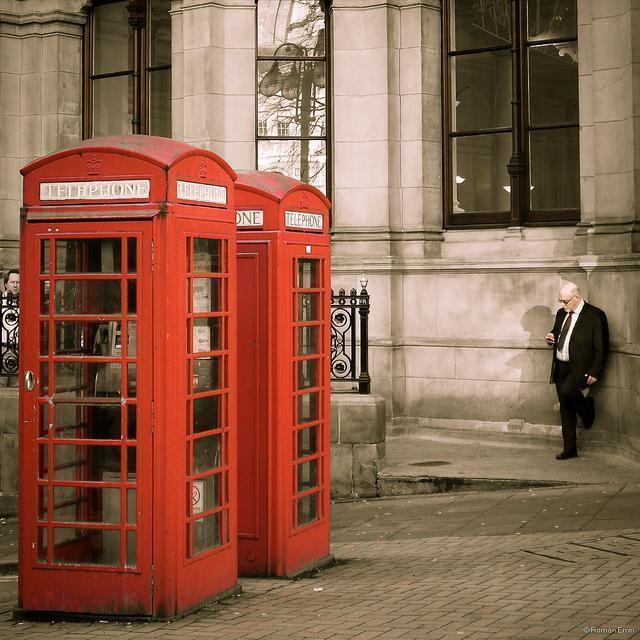If the gentleman here in the suit wants to call his sweetheart where will he do it?
Select the accurate response from the four choices given to answer the question.
Options: Inside building, phone booth, taxi, standing there. Phone booth. 